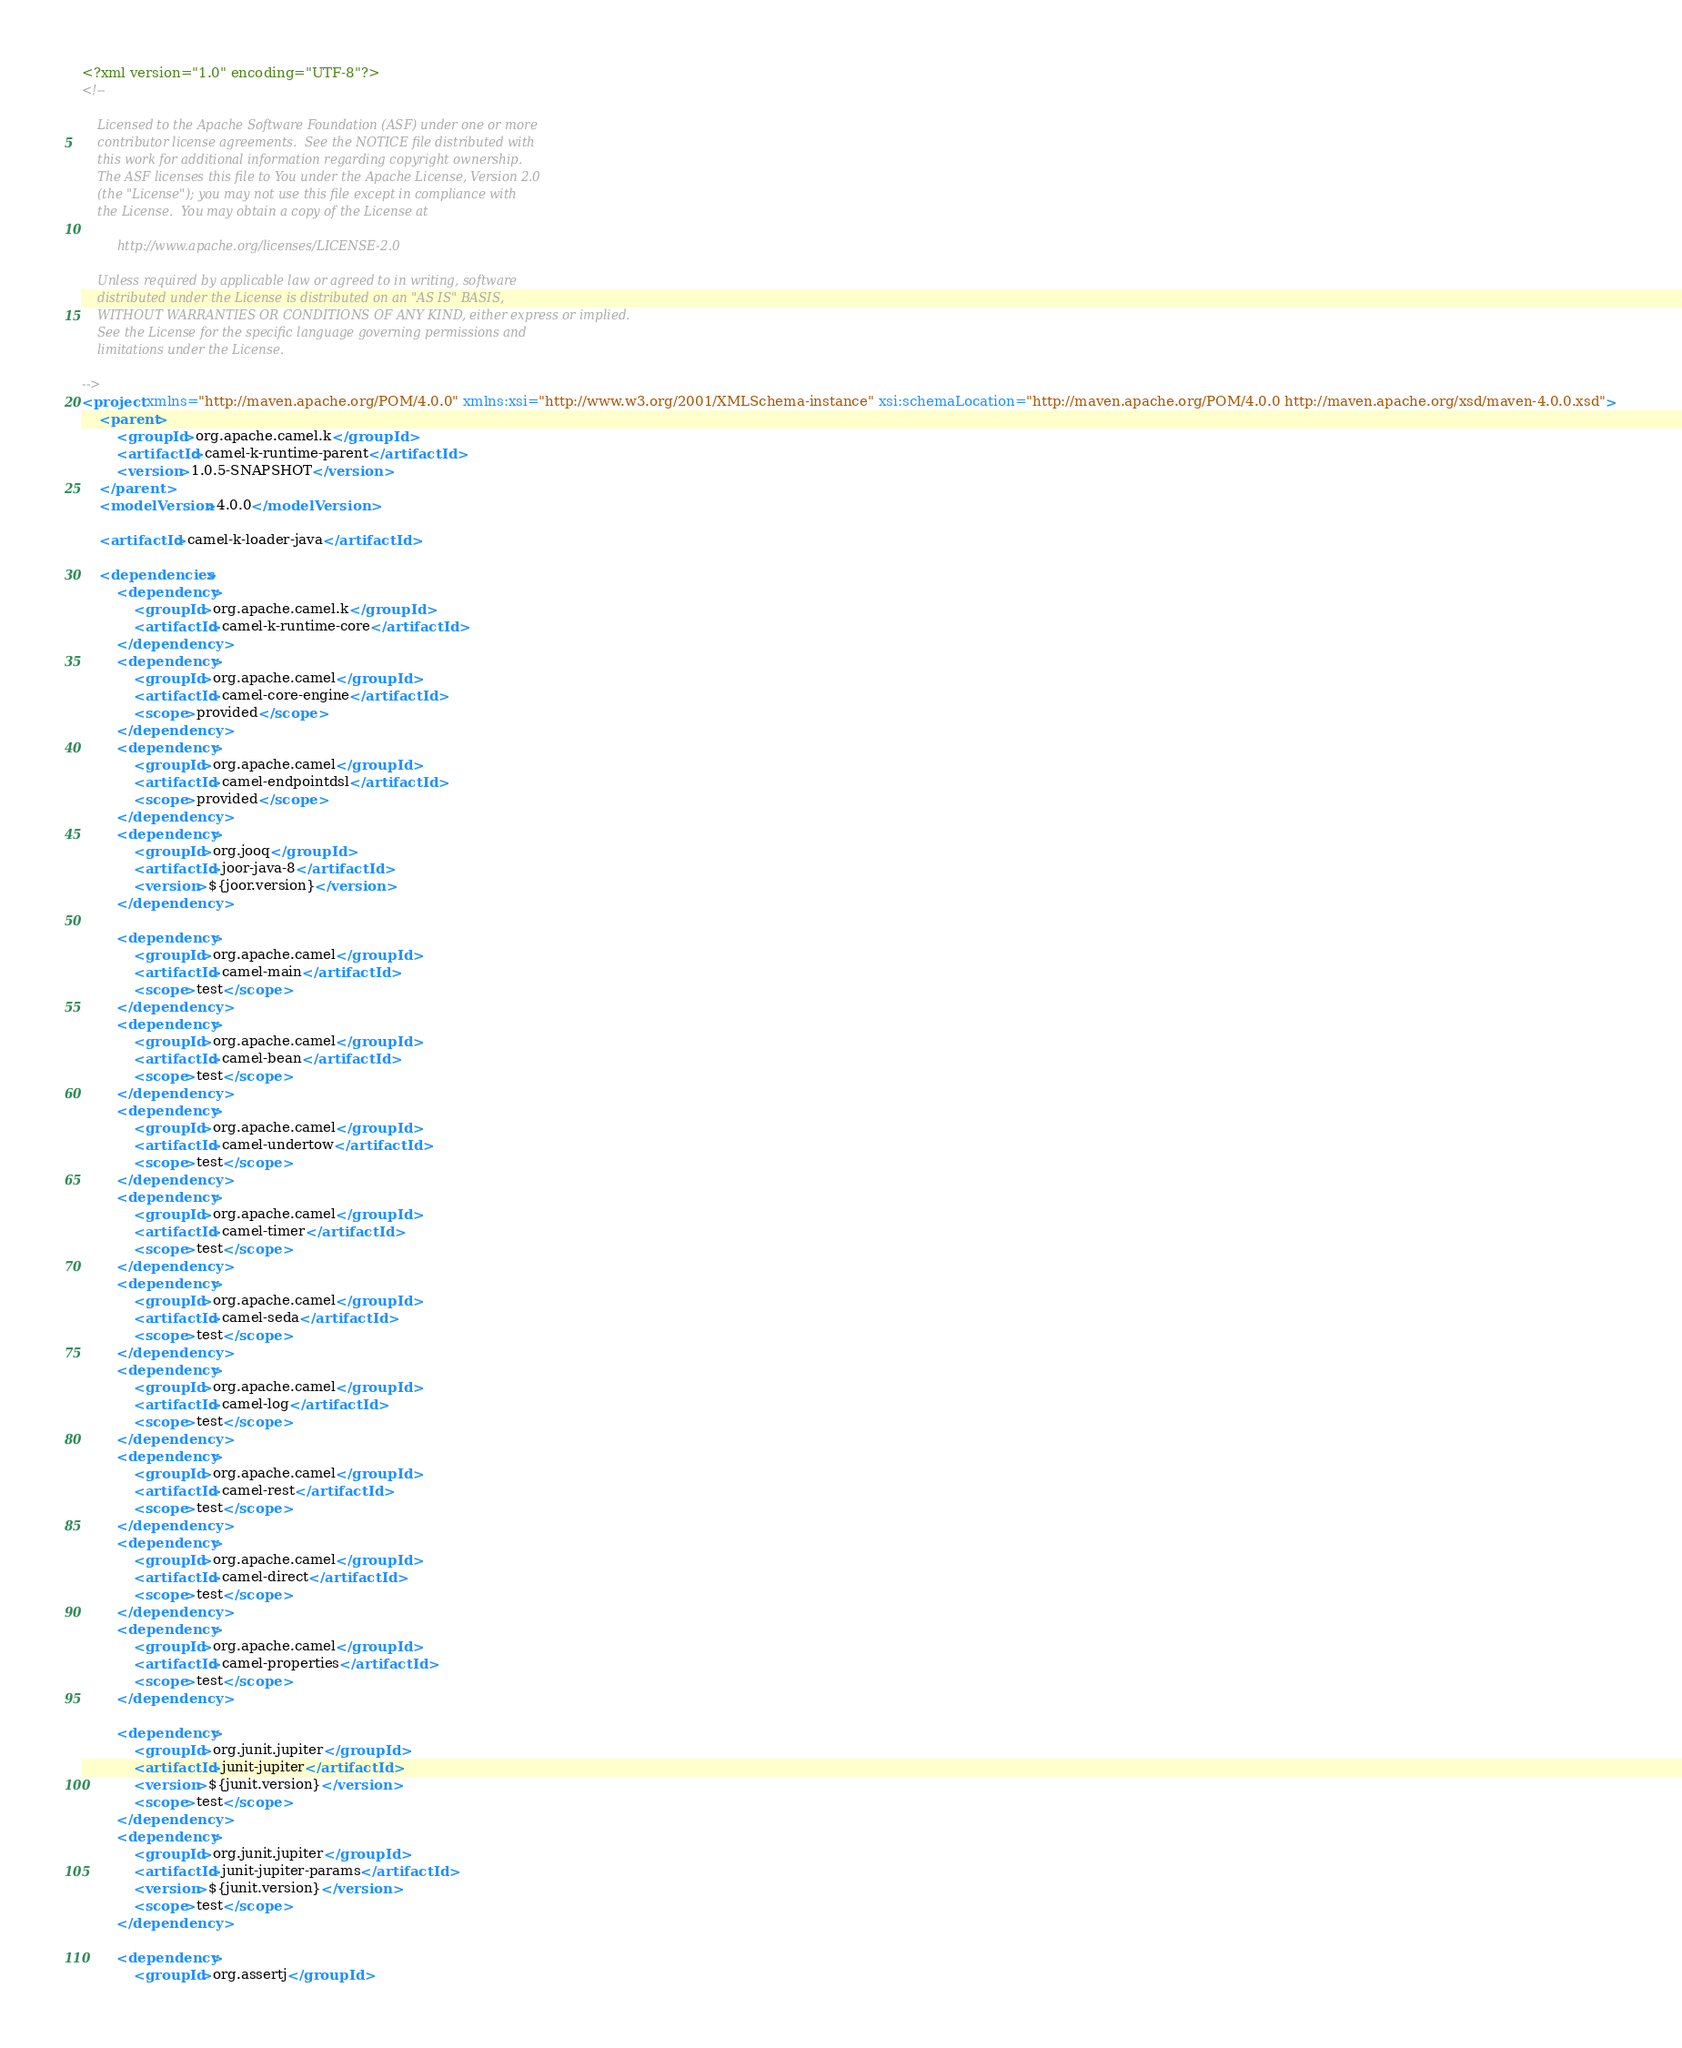Convert code to text. <code><loc_0><loc_0><loc_500><loc_500><_XML_><?xml version="1.0" encoding="UTF-8"?>
<!--

    Licensed to the Apache Software Foundation (ASF) under one or more
    contributor license agreements.  See the NOTICE file distributed with
    this work for additional information regarding copyright ownership.
    The ASF licenses this file to You under the Apache License, Version 2.0
    (the "License"); you may not use this file except in compliance with
    the License.  You may obtain a copy of the License at

         http://www.apache.org/licenses/LICENSE-2.0

    Unless required by applicable law or agreed to in writing, software
    distributed under the License is distributed on an "AS IS" BASIS,
    WITHOUT WARRANTIES OR CONDITIONS OF ANY KIND, either express or implied.
    See the License for the specific language governing permissions and
    limitations under the License.

-->
<project xmlns="http://maven.apache.org/POM/4.0.0" xmlns:xsi="http://www.w3.org/2001/XMLSchema-instance" xsi:schemaLocation="http://maven.apache.org/POM/4.0.0 http://maven.apache.org/xsd/maven-4.0.0.xsd">
    <parent>
        <groupId>org.apache.camel.k</groupId>
        <artifactId>camel-k-runtime-parent</artifactId>
        <version>1.0.5-SNAPSHOT</version>
    </parent>
    <modelVersion>4.0.0</modelVersion>

    <artifactId>camel-k-loader-java</artifactId>

    <dependencies>
        <dependency>
            <groupId>org.apache.camel.k</groupId>
            <artifactId>camel-k-runtime-core</artifactId>
        </dependency>
        <dependency>
            <groupId>org.apache.camel</groupId>
            <artifactId>camel-core-engine</artifactId>
            <scope>provided</scope>
        </dependency>
        <dependency>
            <groupId>org.apache.camel</groupId>
            <artifactId>camel-endpointdsl</artifactId>
            <scope>provided</scope>
        </dependency>
        <dependency>
            <groupId>org.jooq</groupId>
            <artifactId>joor-java-8</artifactId>
            <version>${joor.version}</version>
        </dependency>

        <dependency>
            <groupId>org.apache.camel</groupId>
            <artifactId>camel-main</artifactId>
            <scope>test</scope>
        </dependency>
        <dependency>
            <groupId>org.apache.camel</groupId>
            <artifactId>camel-bean</artifactId>
            <scope>test</scope>
        </dependency>
        <dependency>
            <groupId>org.apache.camel</groupId>
            <artifactId>camel-undertow</artifactId>
            <scope>test</scope>
        </dependency>
        <dependency>
            <groupId>org.apache.camel</groupId>
            <artifactId>camel-timer</artifactId>
            <scope>test</scope>
        </dependency>
        <dependency>
            <groupId>org.apache.camel</groupId>
            <artifactId>camel-seda</artifactId>
            <scope>test</scope>
        </dependency>
        <dependency>
            <groupId>org.apache.camel</groupId>
            <artifactId>camel-log</artifactId>
            <scope>test</scope>
        </dependency>
        <dependency>
            <groupId>org.apache.camel</groupId>
            <artifactId>camel-rest</artifactId>
            <scope>test</scope>
        </dependency>
        <dependency>
            <groupId>org.apache.camel</groupId>
            <artifactId>camel-direct</artifactId>
            <scope>test</scope>
        </dependency>
        <dependency>
            <groupId>org.apache.camel</groupId>
            <artifactId>camel-properties</artifactId>
            <scope>test</scope>
        </dependency>

        <dependency>
            <groupId>org.junit.jupiter</groupId>
            <artifactId>junit-jupiter</artifactId>
            <version>${junit.version}</version>
            <scope>test</scope>
        </dependency>
        <dependency>
            <groupId>org.junit.jupiter</groupId>
            <artifactId>junit-jupiter-params</artifactId>
            <version>${junit.version}</version>
            <scope>test</scope>
        </dependency>

        <dependency>
            <groupId>org.assertj</groupId></code> 